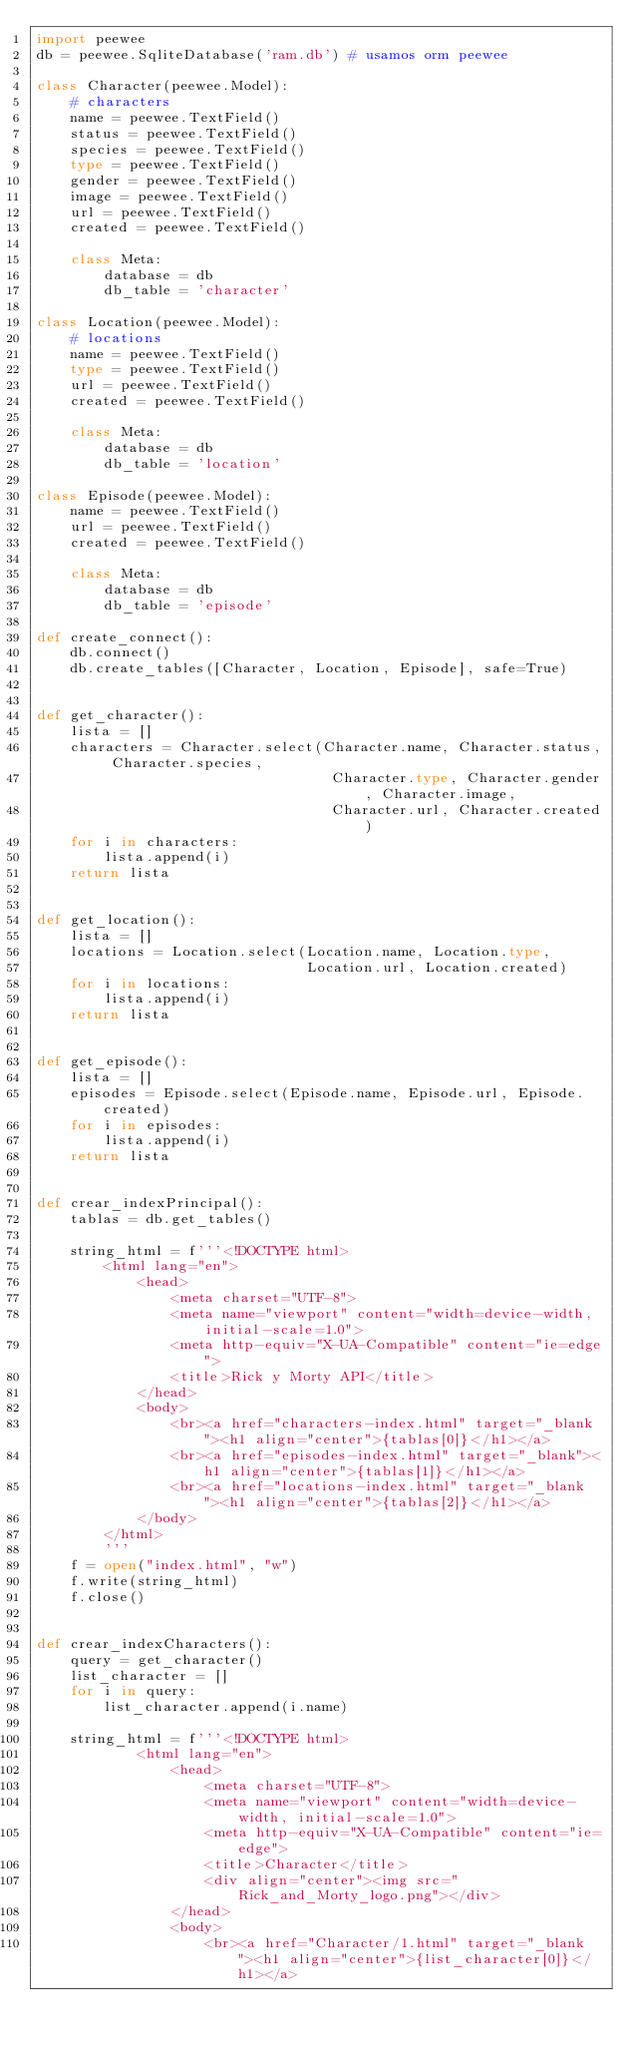Convert code to text. <code><loc_0><loc_0><loc_500><loc_500><_Python_>import peewee
db = peewee.SqliteDatabase('ram.db') # usamos orm peewee

class Character(peewee.Model):
    # characters
    name = peewee.TextField()
    status = peewee.TextField()
    species = peewee.TextField()
    type = peewee.TextField()
    gender = peewee.TextField()
    image = peewee.TextField()
    url = peewee.TextField()
    created = peewee.TextField()

    class Meta:
        database = db
        db_table = 'character'

class Location(peewee.Model):
    # locations
    name = peewee.TextField()
    type = peewee.TextField()
    url = peewee.TextField()
    created = peewee.TextField()

    class Meta:
        database = db
        db_table = 'location'

class Episode(peewee.Model):
    name = peewee.TextField()
    url = peewee.TextField()
    created = peewee.TextField()

    class Meta:
        database = db
        db_table = 'episode'

def create_connect():
    db.connect()
    db.create_tables([Character, Location, Episode], safe=True)


def get_character():
    lista = []
    characters = Character.select(Character.name, Character.status, Character.species,
                                   Character.type, Character.gender, Character.image,
                                   Character.url, Character.created)
    for i in characters:
        lista.append(i)
    return lista


def get_location():
    lista = []
    locations = Location.select(Location.name, Location.type,
                                Location.url, Location.created)
    for i in locations:
        lista.append(i)
    return lista


def get_episode():
    lista = []
    episodes = Episode.select(Episode.name, Episode.url, Episode.created)
    for i in episodes:
        lista.append(i)
    return lista


def crear_indexPrincipal():
    tablas = db.get_tables()

    string_html = f'''<!DOCTYPE html>
        <html lang="en">
            <head>
                <meta charset="UTF-8">
                <meta name="viewport" content="width=device-width, initial-scale=1.0">
                <meta http-equiv="X-UA-Compatible" content="ie=edge">
                <title>Rick y Morty API</title>
            </head>
            <body>
                <br><a href="characters-index.html" target="_blank"><h1 align="center">{tablas[0]}</h1></a>
                <br><a href="episodes-index.html" target="_blank"><h1 align="center">{tablas[1]}</h1></a>
                <br><a href="locations-index.html" target="_blank"><h1 align="center">{tablas[2]}</h1></a>           
            </body>
        </html>
        '''
    f = open("index.html", "w")
    f.write(string_html)
    f.close()


def crear_indexCharacters():
    query = get_character()
    list_character = []
    for i in query:
        list_character.append(i.name)

    string_html = f'''<!DOCTYPE html>
            <html lang="en">
                <head>
                    <meta charset="UTF-8">
                    <meta name="viewport" content="width=device-width, initial-scale=1.0">
                    <meta http-equiv="X-UA-Compatible" content="ie=edge">
                    <title>Character</title>
                    <div align="center"><img src="Rick_and_Morty_logo.png"></div>
                </head>
                <body>
                    <br><a href="Character/1.html" target="_blank"><h1 align="center">{list_character[0]}</h1></a></code> 